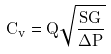<formula> <loc_0><loc_0><loc_500><loc_500>C _ { v } = Q \sqrt { \frac { S G } { \Delta P } }</formula> 